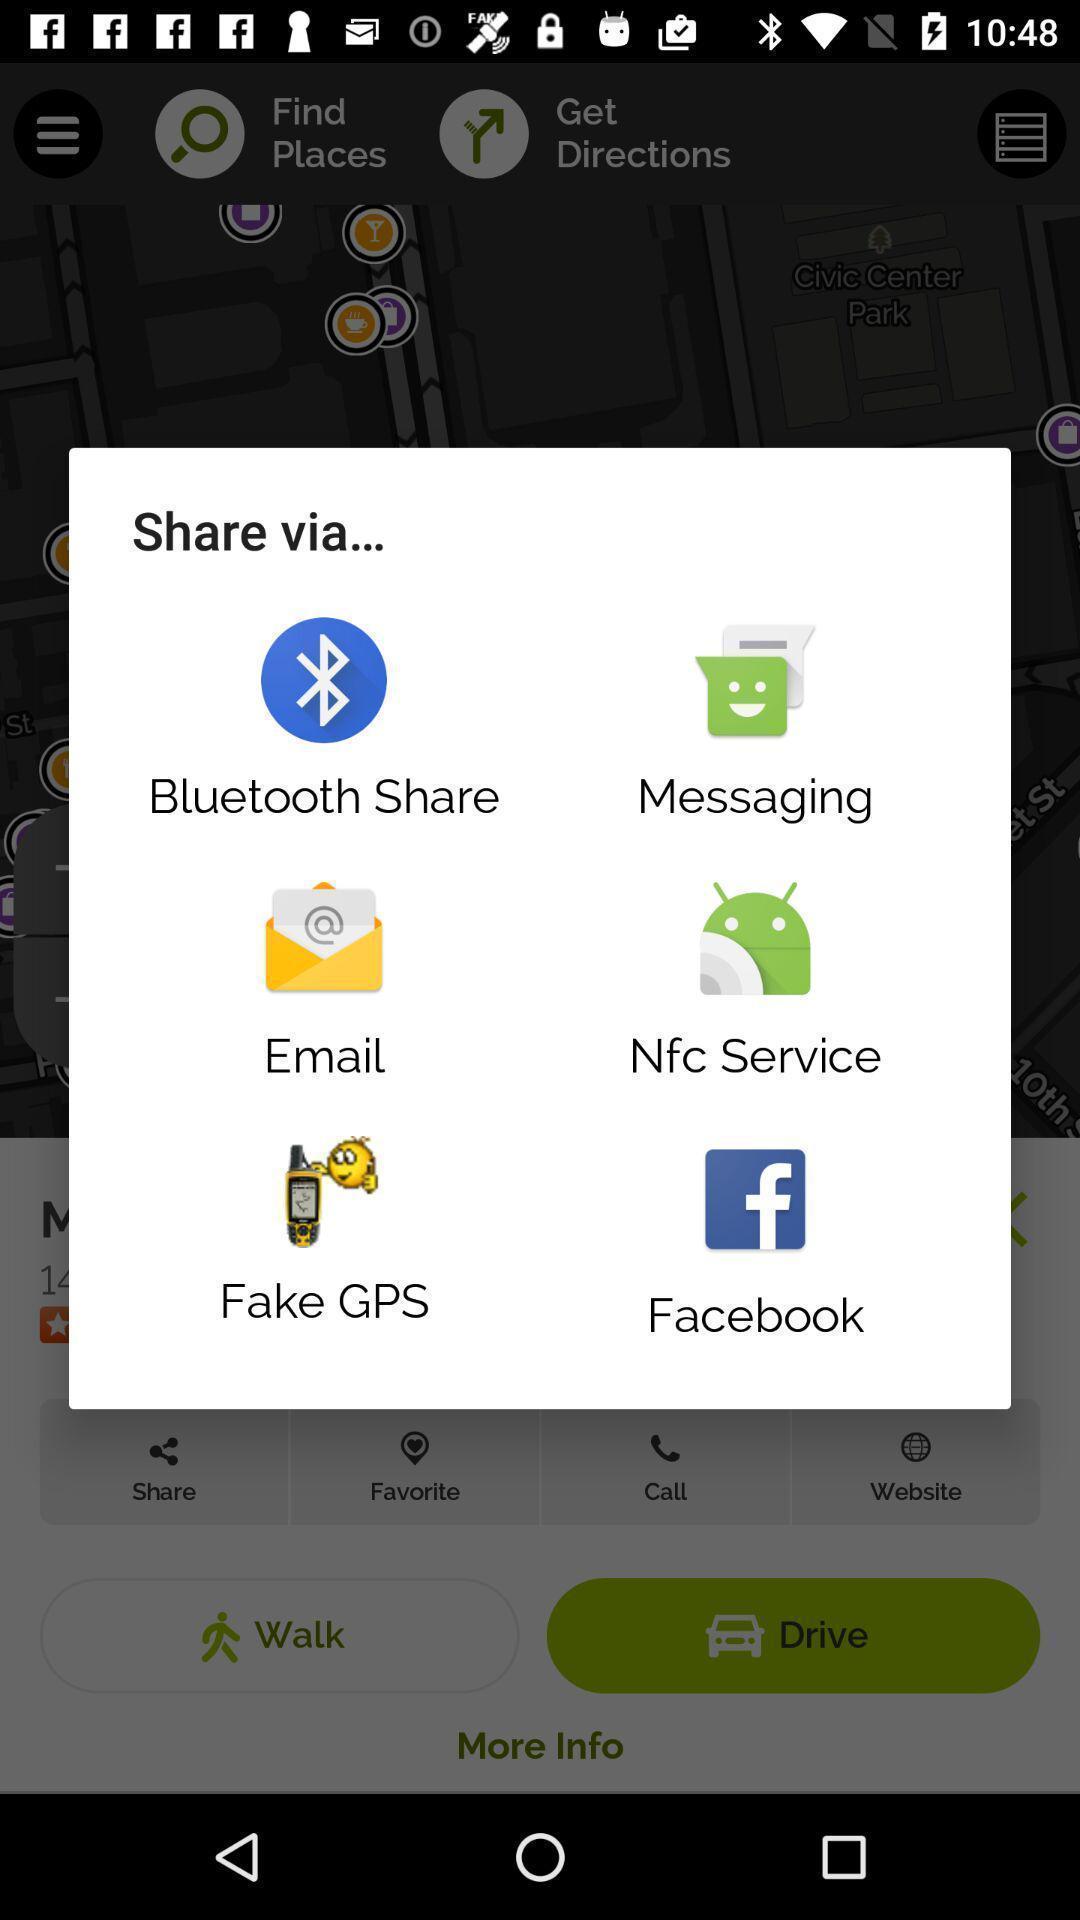Explain the elements present in this screenshot. Pop-up showing multiple application to share. 